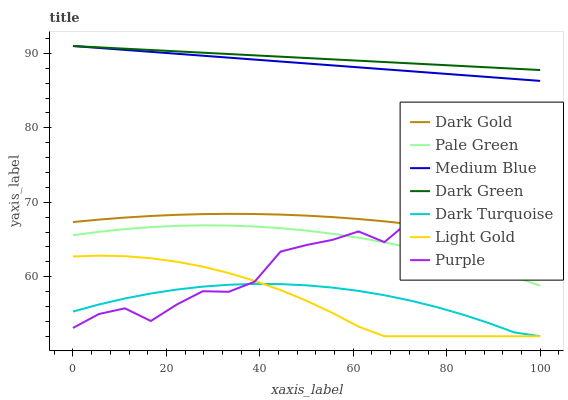Does Light Gold have the minimum area under the curve?
Answer yes or no. Yes. Does Dark Green have the maximum area under the curve?
Answer yes or no. Yes. Does Purple have the minimum area under the curve?
Answer yes or no. No. Does Purple have the maximum area under the curve?
Answer yes or no. No. Is Dark Green the smoothest?
Answer yes or no. Yes. Is Purple the roughest?
Answer yes or no. Yes. Is Dark Turquoise the smoothest?
Answer yes or no. No. Is Dark Turquoise the roughest?
Answer yes or no. No. Does Purple have the lowest value?
Answer yes or no. No. Does Purple have the highest value?
Answer yes or no. No. Is Dark Gold less than Medium Blue?
Answer yes or no. Yes. Is Dark Green greater than Purple?
Answer yes or no. Yes. Does Dark Gold intersect Medium Blue?
Answer yes or no. No. 